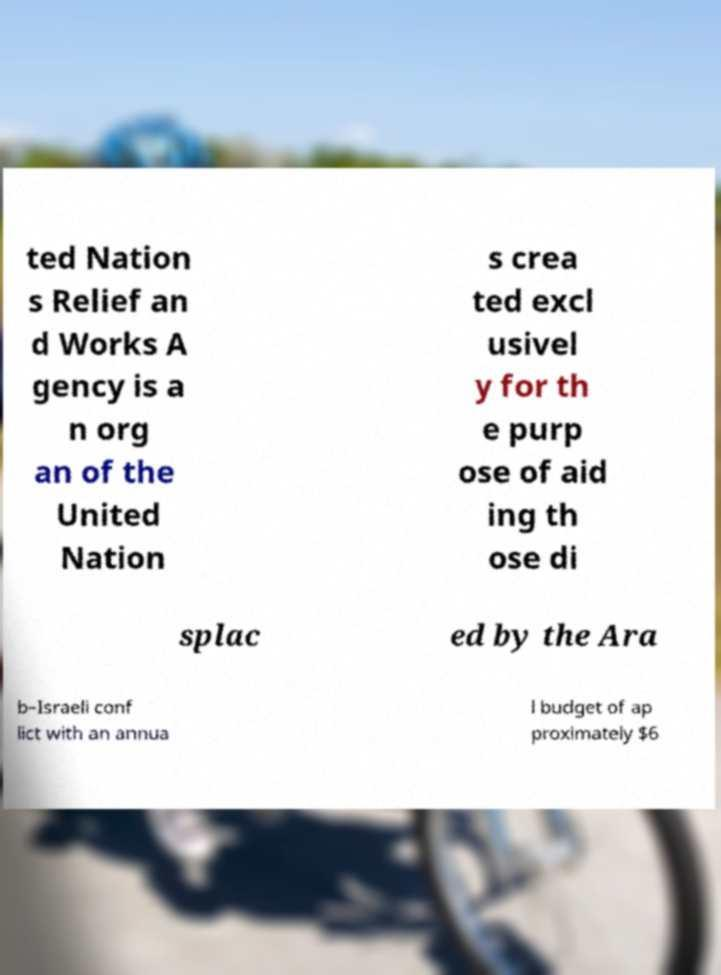What messages or text are displayed in this image? I need them in a readable, typed format. ted Nation s Relief an d Works A gency is a n org an of the United Nation s crea ted excl usivel y for th e purp ose of aid ing th ose di splac ed by the Ara b–Israeli conf lict with an annua l budget of ap proximately $6 